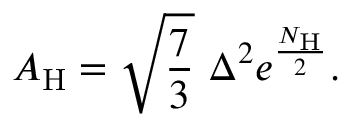Convert formula to latex. <formula><loc_0><loc_0><loc_500><loc_500>A _ { H } = \sqrt { \frac { 7 } { 3 } } \Delta ^ { 2 } e ^ { \frac { N _ { H } } { 2 } } .</formula> 